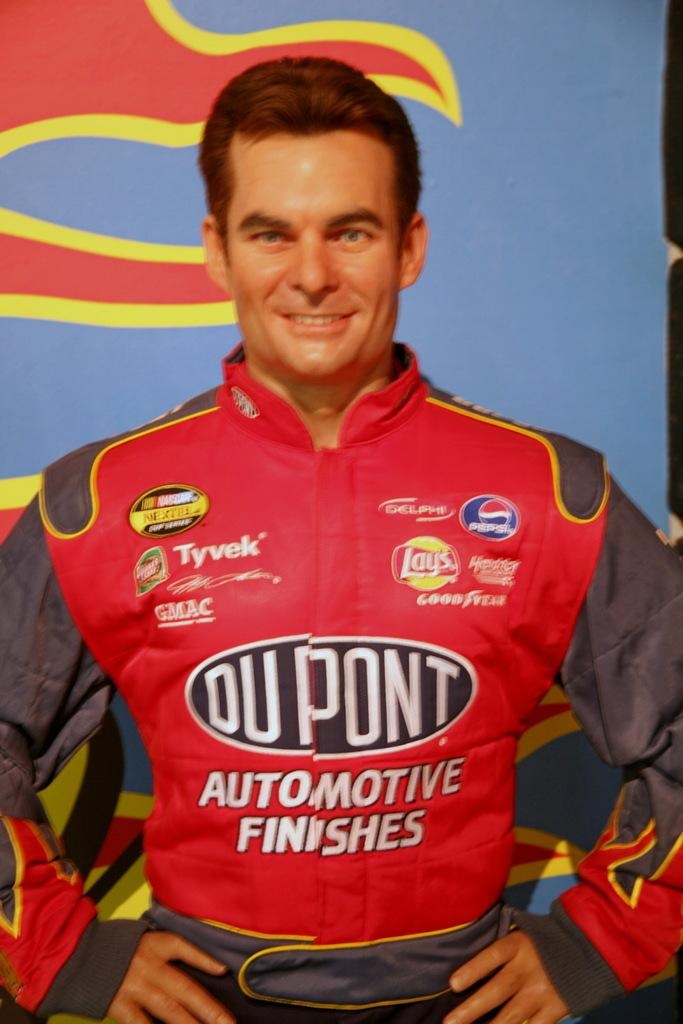Who is present in the image? There is a man in the image. What is the man doing in the image? The man is smiling in the image. What is the man wearing in the image? The man is wearing a red color jacket in the image. What colors of banners can be seen in the image? There is a blue color banner and a red color banner in the image. How many ladybugs are crawling on the man's jacket in the image? There are no ladybugs present on the man's jacket in the image. What message does the peace banner convey in the image? There is no peace banner in the image; only a blue and a red color banner are present. 